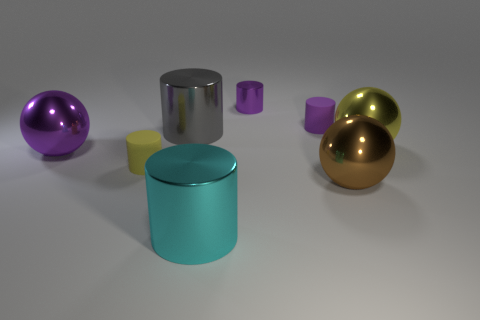Subtract all purple metal cylinders. How many cylinders are left? 4 Subtract all brown spheres. How many spheres are left? 2 Add 1 yellow metal spheres. How many objects exist? 9 Subtract all cylinders. How many objects are left? 3 Subtract 2 spheres. How many spheres are left? 1 Subtract all large purple shiny things. Subtract all large metallic cylinders. How many objects are left? 5 Add 7 purple shiny things. How many purple shiny things are left? 9 Add 8 small red cylinders. How many small red cylinders exist? 8 Subtract 1 yellow spheres. How many objects are left? 7 Subtract all gray cylinders. Subtract all red spheres. How many cylinders are left? 4 